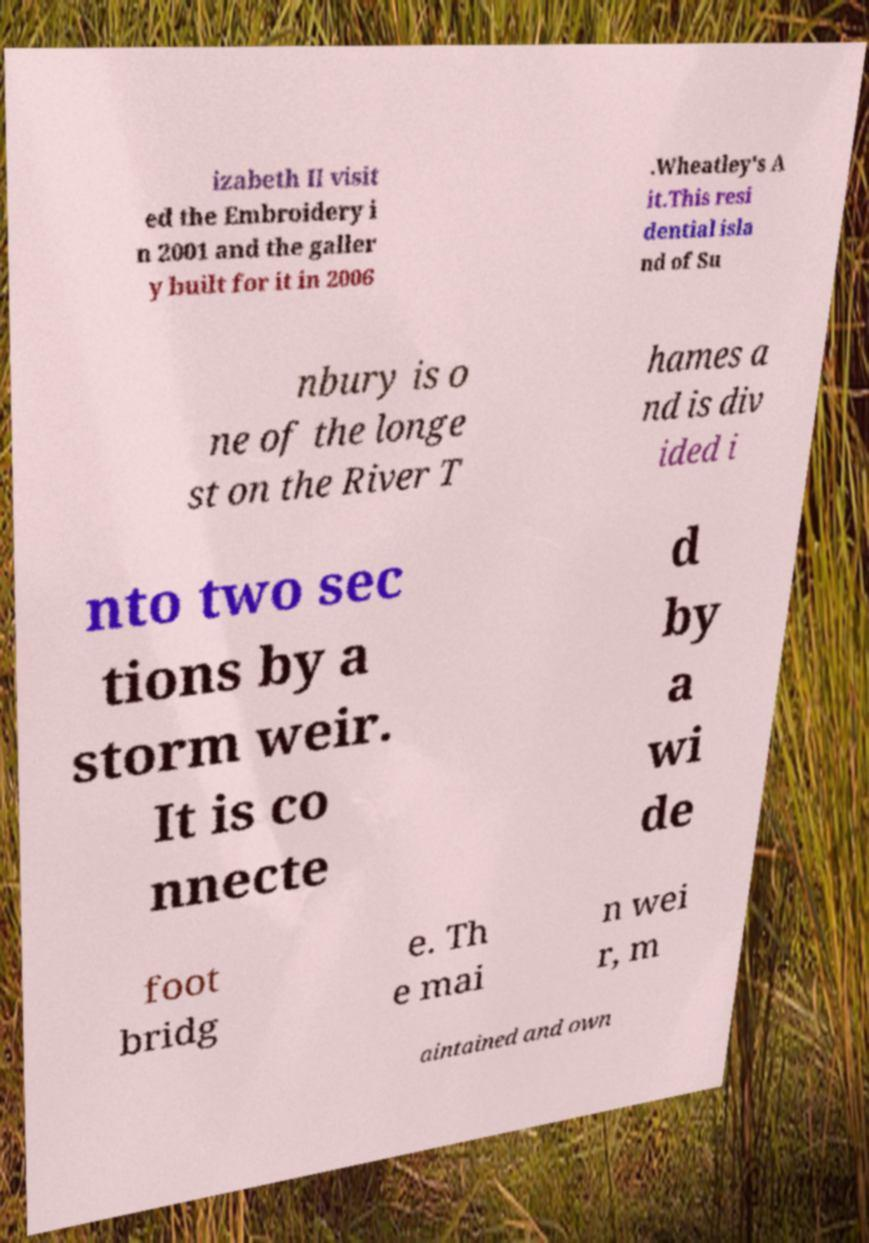Could you extract and type out the text from this image? izabeth II visit ed the Embroidery i n 2001 and the galler y built for it in 2006 .Wheatley's A it.This resi dential isla nd of Su nbury is o ne of the longe st on the River T hames a nd is div ided i nto two sec tions by a storm weir. It is co nnecte d by a wi de foot bridg e. Th e mai n wei r, m aintained and own 